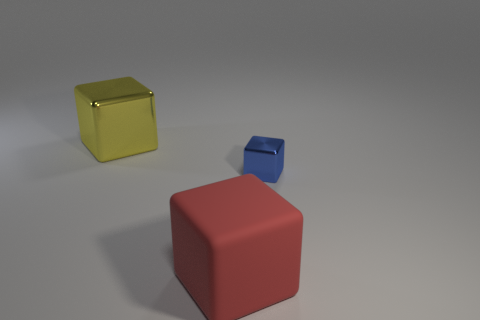There is a big matte thing that is the same shape as the blue metallic thing; what color is it?
Offer a terse response. Red. What number of other matte things have the same color as the large rubber object?
Ensure brevity in your answer.  0. Does the big thing on the left side of the large red thing have the same shape as the blue shiny object?
Provide a short and direct response. Yes. There is a thing in front of the metallic block on the right side of the large object behind the big red rubber cube; what is its shape?
Keep it short and to the point. Cube. How big is the red block?
Your response must be concise. Large. The tiny block that is made of the same material as the large yellow object is what color?
Your answer should be very brief. Blue. How many large yellow blocks have the same material as the tiny blue block?
Give a very brief answer. 1. The large object in front of the metal block that is behind the blue object is what color?
Your answer should be compact. Red. What color is the matte thing that is the same size as the yellow shiny cube?
Your response must be concise. Red. Is there a large yellow metallic thing of the same shape as the blue object?
Your response must be concise. Yes. 